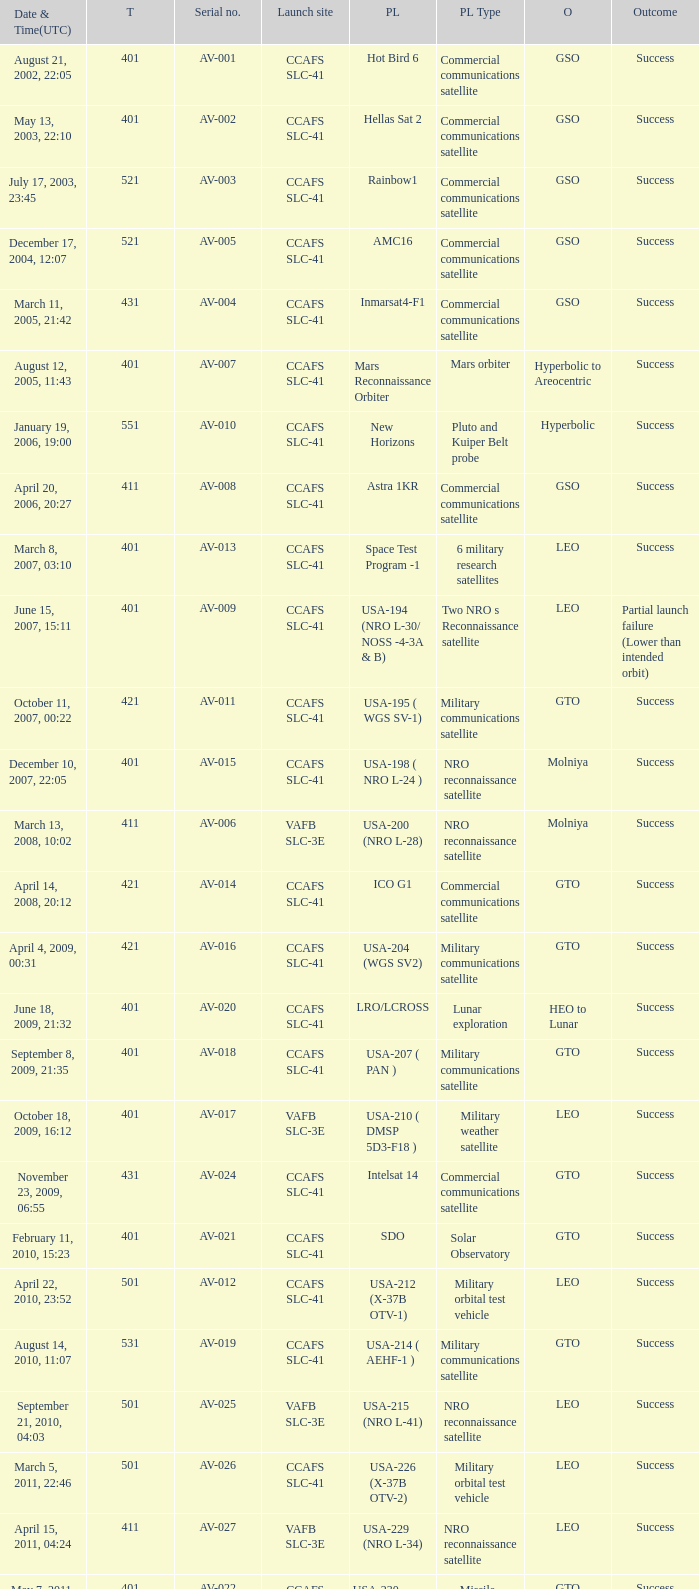What payload was on November 26, 2011, 15:02? Mars rover. 